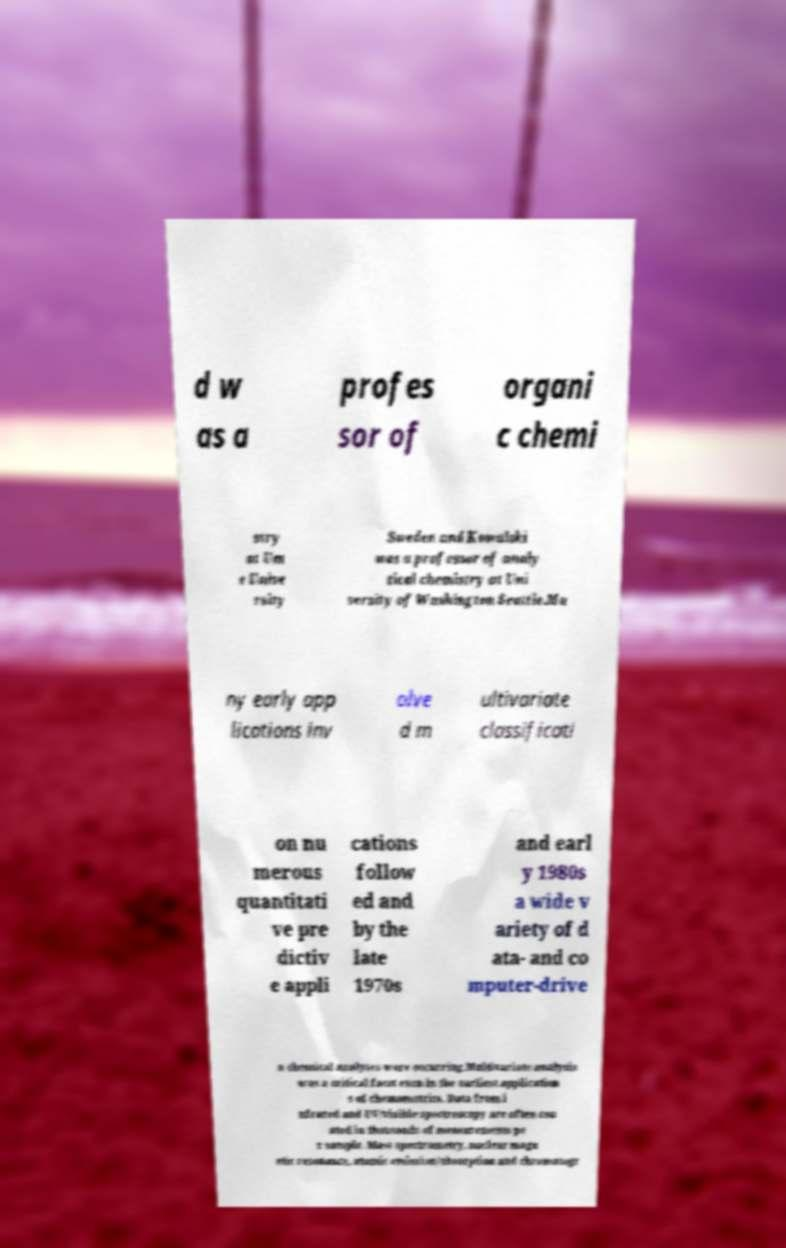There's text embedded in this image that I need extracted. Can you transcribe it verbatim? d w as a profes sor of organi c chemi stry at Um e Unive rsity Sweden and Kowalski was a professor of analy tical chemistry at Uni versity of Washington Seattle.Ma ny early app lications inv olve d m ultivariate classificati on nu merous quantitati ve pre dictiv e appli cations follow ed and by the late 1970s and earl y 1980s a wide v ariety of d ata- and co mputer-drive n chemical analyses were occurring.Multivariate analysis was a critical facet even in the earliest application s of chemometrics. Data from i nfrared and UV/visible spectroscopy are often cou nted in thousands of measurements pe r sample. Mass spectrometry, nuclear magn etic resonance, atomic emission/absorption and chromatogr 